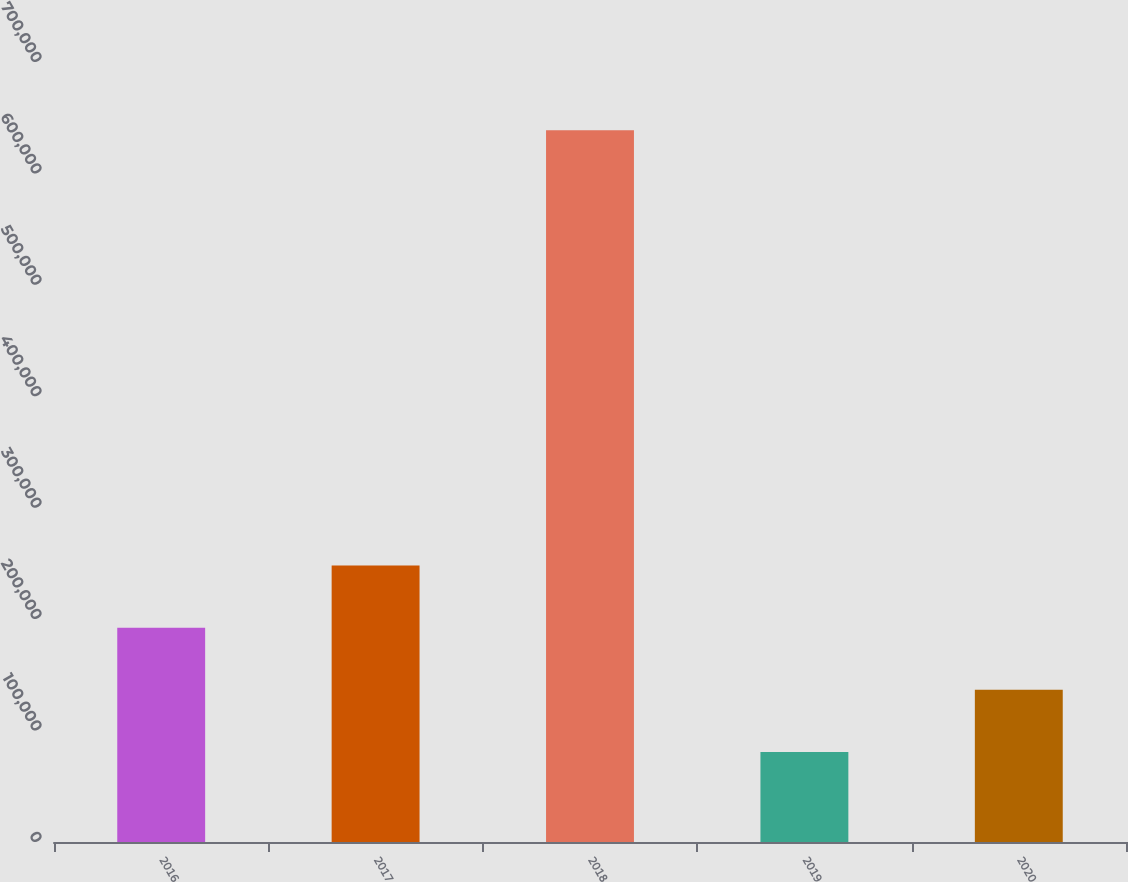Convert chart. <chart><loc_0><loc_0><loc_500><loc_500><bar_chart><fcel>2016<fcel>2017<fcel>2018<fcel>2019<fcel>2020<nl><fcel>192338<fcel>248136<fcel>638728<fcel>80740<fcel>136539<nl></chart> 